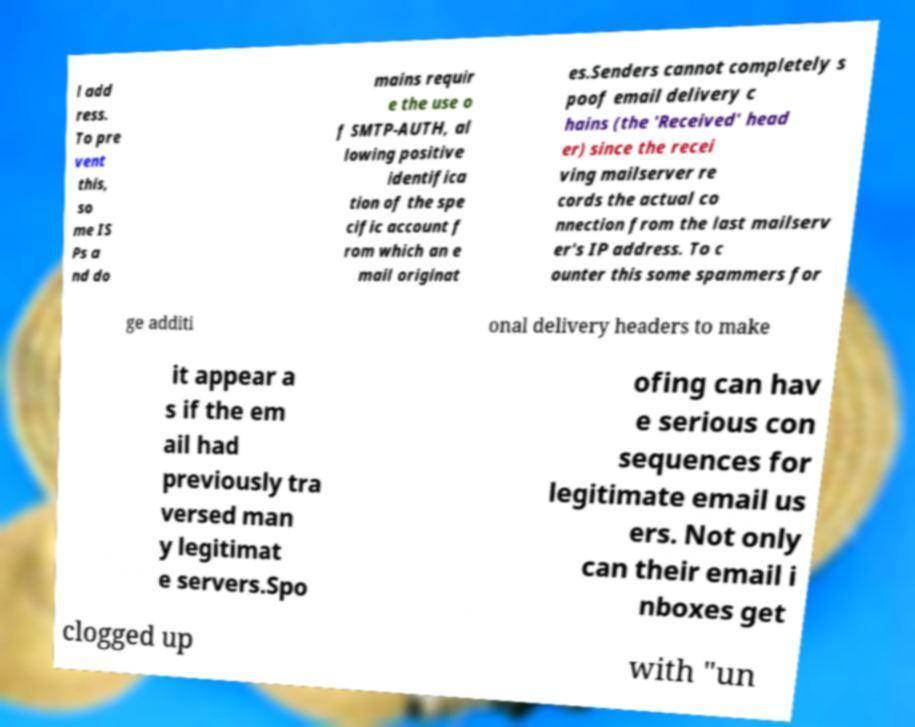Please read and relay the text visible in this image. What does it say? l add ress. To pre vent this, so me IS Ps a nd do mains requir e the use o f SMTP-AUTH, al lowing positive identifica tion of the spe cific account f rom which an e mail originat es.Senders cannot completely s poof email delivery c hains (the 'Received' head er) since the recei ving mailserver re cords the actual co nnection from the last mailserv er's IP address. To c ounter this some spammers for ge additi onal delivery headers to make it appear a s if the em ail had previously tra versed man y legitimat e servers.Spo ofing can hav e serious con sequences for legitimate email us ers. Not only can their email i nboxes get clogged up with "un 